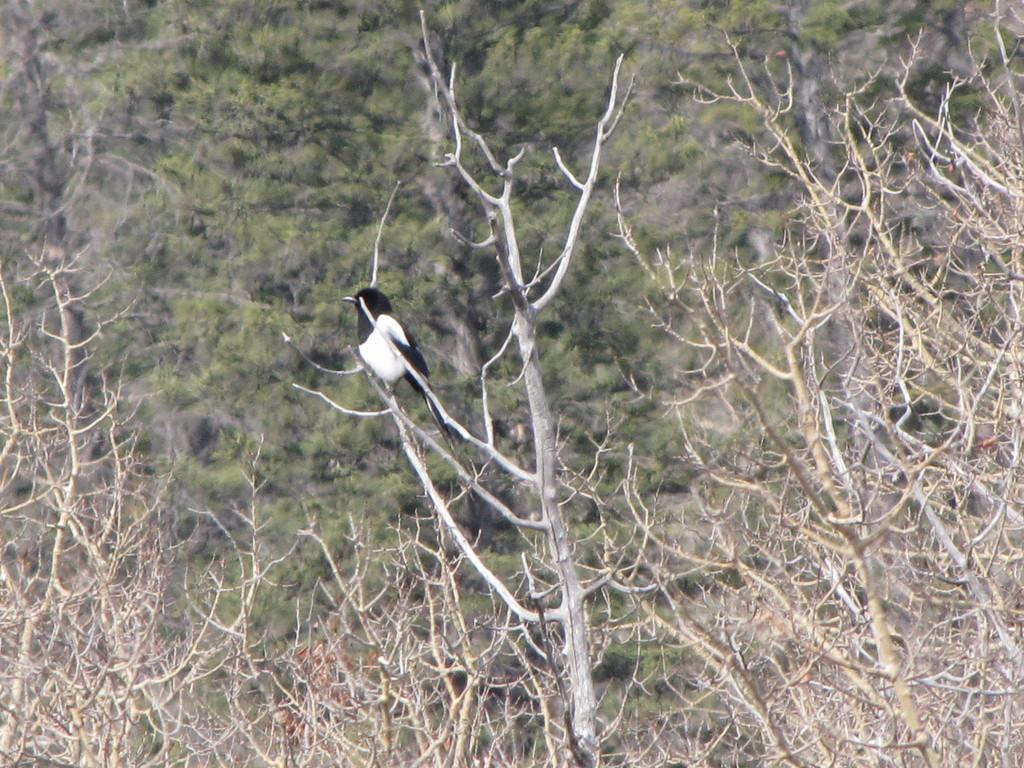Please provide a concise description of this image. In this image I can see number of trees and in the front I can see a white and black colour bird on a tree. 